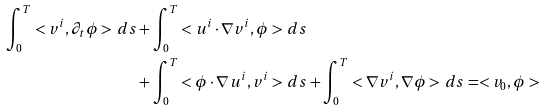<formula> <loc_0><loc_0><loc_500><loc_500>\int _ { 0 } ^ { T } < v ^ { i } , \partial _ { t } \phi > \, d s & + \int _ { 0 } ^ { T } < u ^ { i } \cdot \nabla v ^ { i } , \phi > \, d s \\ & + \int _ { 0 } ^ { T } < \phi \cdot \nabla u ^ { i } , v ^ { i } > \, d s + \int _ { 0 } ^ { T } < \nabla v ^ { i } , \nabla \phi > \, d s = < v _ { 0 } , \phi ></formula> 